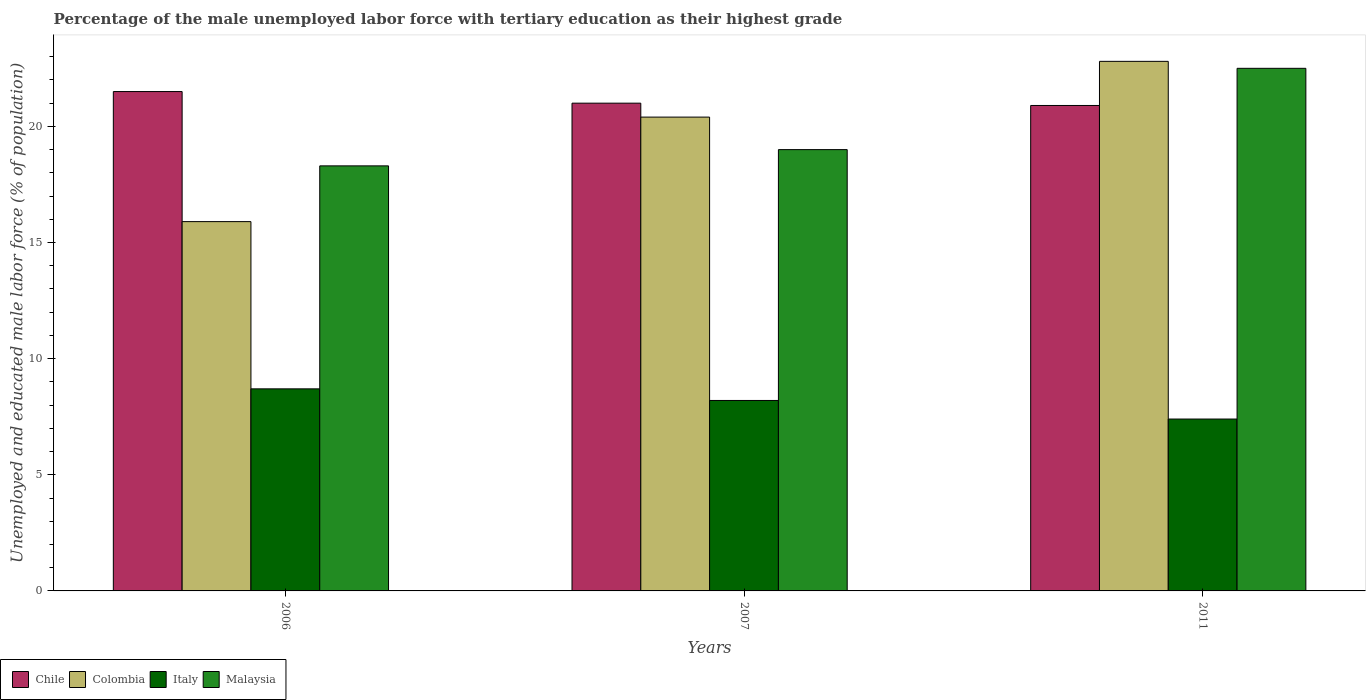How many different coloured bars are there?
Offer a terse response. 4. How many bars are there on the 3rd tick from the left?
Keep it short and to the point. 4. How many bars are there on the 2nd tick from the right?
Provide a succinct answer. 4. What is the label of the 2nd group of bars from the left?
Make the answer very short. 2007. In how many cases, is the number of bars for a given year not equal to the number of legend labels?
Give a very brief answer. 0. What is the percentage of the unemployed male labor force with tertiary education in Italy in 2006?
Ensure brevity in your answer.  8.7. Across all years, what is the maximum percentage of the unemployed male labor force with tertiary education in Italy?
Provide a short and direct response. 8.7. Across all years, what is the minimum percentage of the unemployed male labor force with tertiary education in Colombia?
Your response must be concise. 15.9. In which year was the percentage of the unemployed male labor force with tertiary education in Italy minimum?
Offer a terse response. 2011. What is the total percentage of the unemployed male labor force with tertiary education in Malaysia in the graph?
Give a very brief answer. 59.8. What is the difference between the percentage of the unemployed male labor force with tertiary education in Colombia in 2006 and that in 2011?
Your response must be concise. -6.9. What is the difference between the percentage of the unemployed male labor force with tertiary education in Chile in 2011 and the percentage of the unemployed male labor force with tertiary education in Colombia in 2006?
Make the answer very short. 5. What is the average percentage of the unemployed male labor force with tertiary education in Colombia per year?
Keep it short and to the point. 19.7. In the year 2011, what is the difference between the percentage of the unemployed male labor force with tertiary education in Malaysia and percentage of the unemployed male labor force with tertiary education in Chile?
Give a very brief answer. 1.6. In how many years, is the percentage of the unemployed male labor force with tertiary education in Malaysia greater than 6 %?
Offer a very short reply. 3. What is the ratio of the percentage of the unemployed male labor force with tertiary education in Colombia in 2006 to that in 2011?
Keep it short and to the point. 0.7. Is the percentage of the unemployed male labor force with tertiary education in Italy in 2006 less than that in 2011?
Keep it short and to the point. No. What is the difference between the highest and the second highest percentage of the unemployed male labor force with tertiary education in Malaysia?
Provide a succinct answer. 3.5. What is the difference between the highest and the lowest percentage of the unemployed male labor force with tertiary education in Malaysia?
Ensure brevity in your answer.  4.2. In how many years, is the percentage of the unemployed male labor force with tertiary education in Chile greater than the average percentage of the unemployed male labor force with tertiary education in Chile taken over all years?
Your answer should be compact. 1. Is the sum of the percentage of the unemployed male labor force with tertiary education in Malaysia in 2006 and 2007 greater than the maximum percentage of the unemployed male labor force with tertiary education in Chile across all years?
Your answer should be compact. Yes. Is it the case that in every year, the sum of the percentage of the unemployed male labor force with tertiary education in Chile and percentage of the unemployed male labor force with tertiary education in Colombia is greater than the sum of percentage of the unemployed male labor force with tertiary education in Italy and percentage of the unemployed male labor force with tertiary education in Malaysia?
Your answer should be very brief. No. Is it the case that in every year, the sum of the percentage of the unemployed male labor force with tertiary education in Chile and percentage of the unemployed male labor force with tertiary education in Malaysia is greater than the percentage of the unemployed male labor force with tertiary education in Italy?
Keep it short and to the point. Yes. Are all the bars in the graph horizontal?
Give a very brief answer. No. How many years are there in the graph?
Your answer should be very brief. 3. Are the values on the major ticks of Y-axis written in scientific E-notation?
Keep it short and to the point. No. Does the graph contain any zero values?
Provide a succinct answer. No. Does the graph contain grids?
Make the answer very short. No. Where does the legend appear in the graph?
Offer a very short reply. Bottom left. How are the legend labels stacked?
Offer a very short reply. Horizontal. What is the title of the graph?
Offer a very short reply. Percentage of the male unemployed labor force with tertiary education as their highest grade. What is the label or title of the Y-axis?
Give a very brief answer. Unemployed and educated male labor force (% of population). What is the Unemployed and educated male labor force (% of population) of Colombia in 2006?
Your response must be concise. 15.9. What is the Unemployed and educated male labor force (% of population) in Italy in 2006?
Your response must be concise. 8.7. What is the Unemployed and educated male labor force (% of population) of Malaysia in 2006?
Ensure brevity in your answer.  18.3. What is the Unemployed and educated male labor force (% of population) in Chile in 2007?
Give a very brief answer. 21. What is the Unemployed and educated male labor force (% of population) in Colombia in 2007?
Give a very brief answer. 20.4. What is the Unemployed and educated male labor force (% of population) in Italy in 2007?
Provide a succinct answer. 8.2. What is the Unemployed and educated male labor force (% of population) in Chile in 2011?
Provide a short and direct response. 20.9. What is the Unemployed and educated male labor force (% of population) of Colombia in 2011?
Your answer should be very brief. 22.8. What is the Unemployed and educated male labor force (% of population) of Italy in 2011?
Offer a terse response. 7.4. Across all years, what is the maximum Unemployed and educated male labor force (% of population) of Colombia?
Provide a succinct answer. 22.8. Across all years, what is the maximum Unemployed and educated male labor force (% of population) of Italy?
Provide a succinct answer. 8.7. Across all years, what is the maximum Unemployed and educated male labor force (% of population) in Malaysia?
Your answer should be compact. 22.5. Across all years, what is the minimum Unemployed and educated male labor force (% of population) of Chile?
Provide a short and direct response. 20.9. Across all years, what is the minimum Unemployed and educated male labor force (% of population) in Colombia?
Your response must be concise. 15.9. Across all years, what is the minimum Unemployed and educated male labor force (% of population) of Italy?
Make the answer very short. 7.4. Across all years, what is the minimum Unemployed and educated male labor force (% of population) of Malaysia?
Your answer should be very brief. 18.3. What is the total Unemployed and educated male labor force (% of population) in Chile in the graph?
Keep it short and to the point. 63.4. What is the total Unemployed and educated male labor force (% of population) of Colombia in the graph?
Your response must be concise. 59.1. What is the total Unemployed and educated male labor force (% of population) of Italy in the graph?
Your answer should be compact. 24.3. What is the total Unemployed and educated male labor force (% of population) in Malaysia in the graph?
Offer a very short reply. 59.8. What is the difference between the Unemployed and educated male labor force (% of population) of Chile in 2006 and that in 2007?
Ensure brevity in your answer.  0.5. What is the difference between the Unemployed and educated male labor force (% of population) in Colombia in 2006 and that in 2011?
Give a very brief answer. -6.9. What is the difference between the Unemployed and educated male labor force (% of population) in Italy in 2006 and that in 2011?
Your answer should be very brief. 1.3. What is the difference between the Unemployed and educated male labor force (% of population) of Malaysia in 2006 and that in 2011?
Offer a very short reply. -4.2. What is the difference between the Unemployed and educated male labor force (% of population) in Chile in 2007 and that in 2011?
Give a very brief answer. 0.1. What is the difference between the Unemployed and educated male labor force (% of population) in Italy in 2007 and that in 2011?
Ensure brevity in your answer.  0.8. What is the difference between the Unemployed and educated male labor force (% of population) of Chile in 2006 and the Unemployed and educated male labor force (% of population) of Italy in 2007?
Offer a very short reply. 13.3. What is the difference between the Unemployed and educated male labor force (% of population) in Chile in 2006 and the Unemployed and educated male labor force (% of population) in Malaysia in 2007?
Your response must be concise. 2.5. What is the difference between the Unemployed and educated male labor force (% of population) of Colombia in 2006 and the Unemployed and educated male labor force (% of population) of Italy in 2007?
Your response must be concise. 7.7. What is the difference between the Unemployed and educated male labor force (% of population) in Colombia in 2006 and the Unemployed and educated male labor force (% of population) in Malaysia in 2007?
Offer a terse response. -3.1. What is the difference between the Unemployed and educated male labor force (% of population) in Italy in 2006 and the Unemployed and educated male labor force (% of population) in Malaysia in 2007?
Give a very brief answer. -10.3. What is the difference between the Unemployed and educated male labor force (% of population) in Italy in 2006 and the Unemployed and educated male labor force (% of population) in Malaysia in 2011?
Make the answer very short. -13.8. What is the difference between the Unemployed and educated male labor force (% of population) in Chile in 2007 and the Unemployed and educated male labor force (% of population) in Colombia in 2011?
Offer a terse response. -1.8. What is the difference between the Unemployed and educated male labor force (% of population) of Chile in 2007 and the Unemployed and educated male labor force (% of population) of Malaysia in 2011?
Offer a terse response. -1.5. What is the difference between the Unemployed and educated male labor force (% of population) of Colombia in 2007 and the Unemployed and educated male labor force (% of population) of Italy in 2011?
Keep it short and to the point. 13. What is the difference between the Unemployed and educated male labor force (% of population) in Italy in 2007 and the Unemployed and educated male labor force (% of population) in Malaysia in 2011?
Provide a succinct answer. -14.3. What is the average Unemployed and educated male labor force (% of population) of Chile per year?
Offer a terse response. 21.13. What is the average Unemployed and educated male labor force (% of population) in Malaysia per year?
Your answer should be very brief. 19.93. In the year 2006, what is the difference between the Unemployed and educated male labor force (% of population) of Chile and Unemployed and educated male labor force (% of population) of Colombia?
Ensure brevity in your answer.  5.6. In the year 2006, what is the difference between the Unemployed and educated male labor force (% of population) of Colombia and Unemployed and educated male labor force (% of population) of Italy?
Provide a short and direct response. 7.2. In the year 2006, what is the difference between the Unemployed and educated male labor force (% of population) of Colombia and Unemployed and educated male labor force (% of population) of Malaysia?
Keep it short and to the point. -2.4. In the year 2006, what is the difference between the Unemployed and educated male labor force (% of population) of Italy and Unemployed and educated male labor force (% of population) of Malaysia?
Keep it short and to the point. -9.6. In the year 2007, what is the difference between the Unemployed and educated male labor force (% of population) of Colombia and Unemployed and educated male labor force (% of population) of Italy?
Provide a succinct answer. 12.2. In the year 2007, what is the difference between the Unemployed and educated male labor force (% of population) in Colombia and Unemployed and educated male labor force (% of population) in Malaysia?
Make the answer very short. 1.4. In the year 2007, what is the difference between the Unemployed and educated male labor force (% of population) of Italy and Unemployed and educated male labor force (% of population) of Malaysia?
Keep it short and to the point. -10.8. In the year 2011, what is the difference between the Unemployed and educated male labor force (% of population) of Chile and Unemployed and educated male labor force (% of population) of Colombia?
Ensure brevity in your answer.  -1.9. In the year 2011, what is the difference between the Unemployed and educated male labor force (% of population) in Chile and Unemployed and educated male labor force (% of population) in Italy?
Your response must be concise. 13.5. In the year 2011, what is the difference between the Unemployed and educated male labor force (% of population) in Colombia and Unemployed and educated male labor force (% of population) in Italy?
Offer a very short reply. 15.4. In the year 2011, what is the difference between the Unemployed and educated male labor force (% of population) of Colombia and Unemployed and educated male labor force (% of population) of Malaysia?
Your answer should be compact. 0.3. In the year 2011, what is the difference between the Unemployed and educated male labor force (% of population) in Italy and Unemployed and educated male labor force (% of population) in Malaysia?
Ensure brevity in your answer.  -15.1. What is the ratio of the Unemployed and educated male labor force (% of population) in Chile in 2006 to that in 2007?
Keep it short and to the point. 1.02. What is the ratio of the Unemployed and educated male labor force (% of population) in Colombia in 2006 to that in 2007?
Offer a terse response. 0.78. What is the ratio of the Unemployed and educated male labor force (% of population) of Italy in 2006 to that in 2007?
Offer a terse response. 1.06. What is the ratio of the Unemployed and educated male labor force (% of population) in Malaysia in 2006 to that in 2007?
Your answer should be compact. 0.96. What is the ratio of the Unemployed and educated male labor force (% of population) of Chile in 2006 to that in 2011?
Give a very brief answer. 1.03. What is the ratio of the Unemployed and educated male labor force (% of population) in Colombia in 2006 to that in 2011?
Offer a terse response. 0.7. What is the ratio of the Unemployed and educated male labor force (% of population) in Italy in 2006 to that in 2011?
Make the answer very short. 1.18. What is the ratio of the Unemployed and educated male labor force (% of population) of Malaysia in 2006 to that in 2011?
Ensure brevity in your answer.  0.81. What is the ratio of the Unemployed and educated male labor force (% of population) in Colombia in 2007 to that in 2011?
Your response must be concise. 0.89. What is the ratio of the Unemployed and educated male labor force (% of population) of Italy in 2007 to that in 2011?
Your response must be concise. 1.11. What is the ratio of the Unemployed and educated male labor force (% of population) of Malaysia in 2007 to that in 2011?
Ensure brevity in your answer.  0.84. What is the difference between the highest and the second highest Unemployed and educated male labor force (% of population) in Colombia?
Keep it short and to the point. 2.4. What is the difference between the highest and the second highest Unemployed and educated male labor force (% of population) in Italy?
Make the answer very short. 0.5. What is the difference between the highest and the lowest Unemployed and educated male labor force (% of population) in Chile?
Your answer should be compact. 0.6. What is the difference between the highest and the lowest Unemployed and educated male labor force (% of population) in Malaysia?
Ensure brevity in your answer.  4.2. 